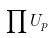Convert formula to latex. <formula><loc_0><loc_0><loc_500><loc_500>\prod U _ { p }</formula> 